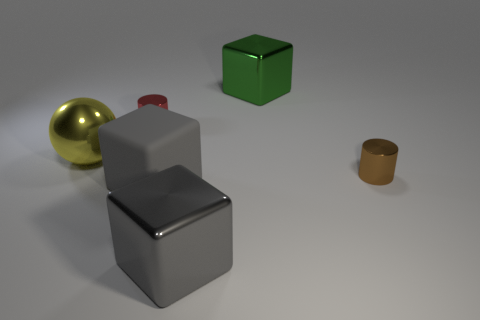Subtract all big metal blocks. How many blocks are left? 1 Add 3 small brown metallic balls. How many objects exist? 9 Subtract all spheres. How many objects are left? 5 Add 2 big green metallic things. How many big green metallic things are left? 3 Add 3 big metal cubes. How many big metal cubes exist? 5 Subtract 0 gray balls. How many objects are left? 6 Subtract all tiny gray metallic spheres. Subtract all rubber cubes. How many objects are left? 5 